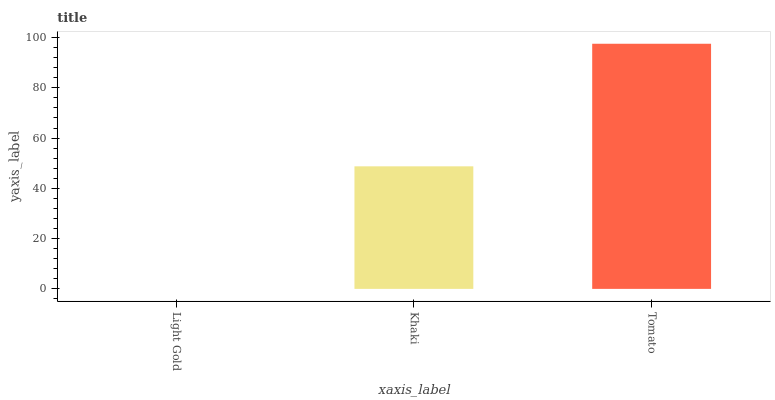Is Light Gold the minimum?
Answer yes or no. Yes. Is Tomato the maximum?
Answer yes or no. Yes. Is Khaki the minimum?
Answer yes or no. No. Is Khaki the maximum?
Answer yes or no. No. Is Khaki greater than Light Gold?
Answer yes or no. Yes. Is Light Gold less than Khaki?
Answer yes or no. Yes. Is Light Gold greater than Khaki?
Answer yes or no. No. Is Khaki less than Light Gold?
Answer yes or no. No. Is Khaki the high median?
Answer yes or no. Yes. Is Khaki the low median?
Answer yes or no. Yes. Is Light Gold the high median?
Answer yes or no. No. Is Light Gold the low median?
Answer yes or no. No. 